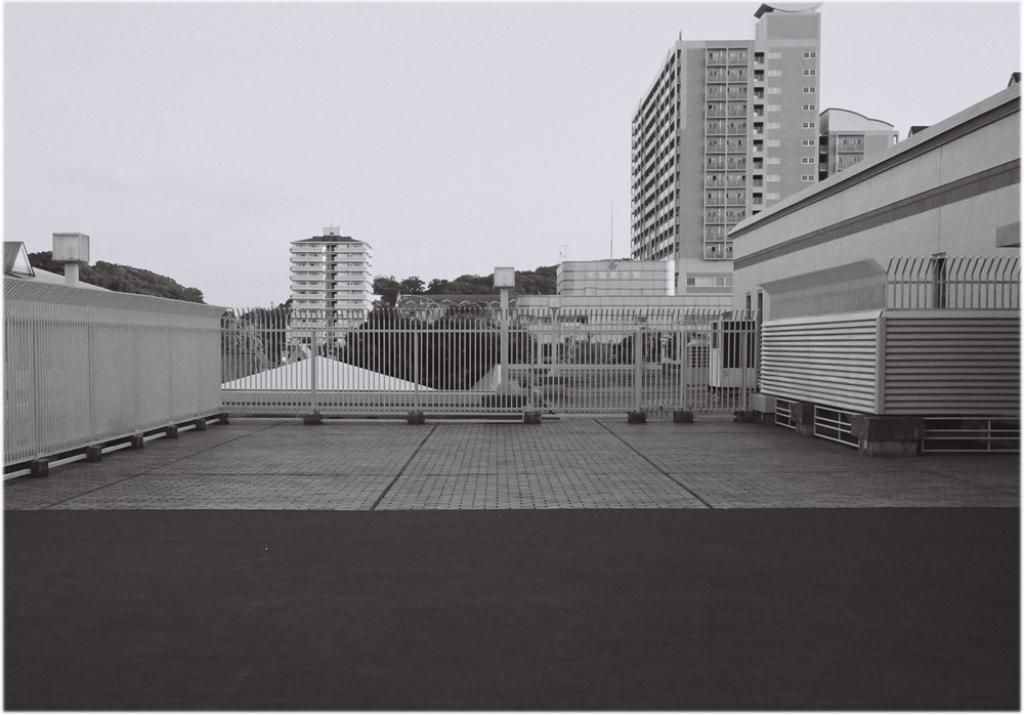What is the color scheme of the image? The image is black and white. What type of structures can be seen in the image? There are buildings in the image. What natural elements are present in the image? There are trees in the image. What architectural features are visible in the image? Windows, a fence, and poles are present in the image. What type of illumination is visible in the image? Lights are visible in the image. What part of the natural environment is visible in the image? The sky is visible in the image. What type of sweater is the father wearing in the image? There is no father or sweater present in the image. What is the tendency of the trees in the image? The image does not provide information about the tendency of the trees; it only shows their presence. 